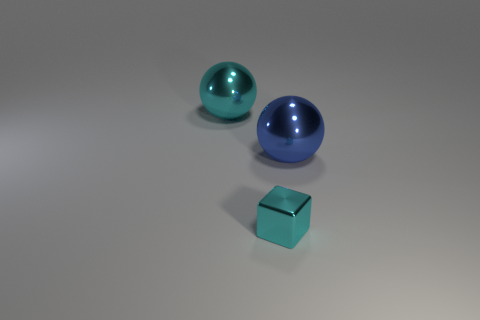Does the big sphere right of the cube have the same material as the cyan cube?
Your answer should be compact. Yes. There is another metallic object that is the same shape as the large blue metallic thing; what is its color?
Your response must be concise. Cyan. How many other objects are there of the same color as the metallic cube?
Provide a short and direct response. 1. Does the big object that is left of the blue ball have the same shape as the thing that is in front of the big blue metallic thing?
Keep it short and to the point. No. What number of spheres are metal things or blue shiny objects?
Offer a terse response. 2. Is the number of big balls to the left of the blue metal ball less than the number of big purple things?
Ensure brevity in your answer.  No. How many other objects are the same material as the tiny block?
Your response must be concise. 2. Does the cyan metal cube have the same size as the cyan sphere?
Your answer should be very brief. No. How many objects are things in front of the large blue thing or small cyan metallic blocks?
Give a very brief answer. 1. There is a object in front of the large sphere in front of the large cyan metallic sphere; what is its material?
Offer a very short reply. Metal. 